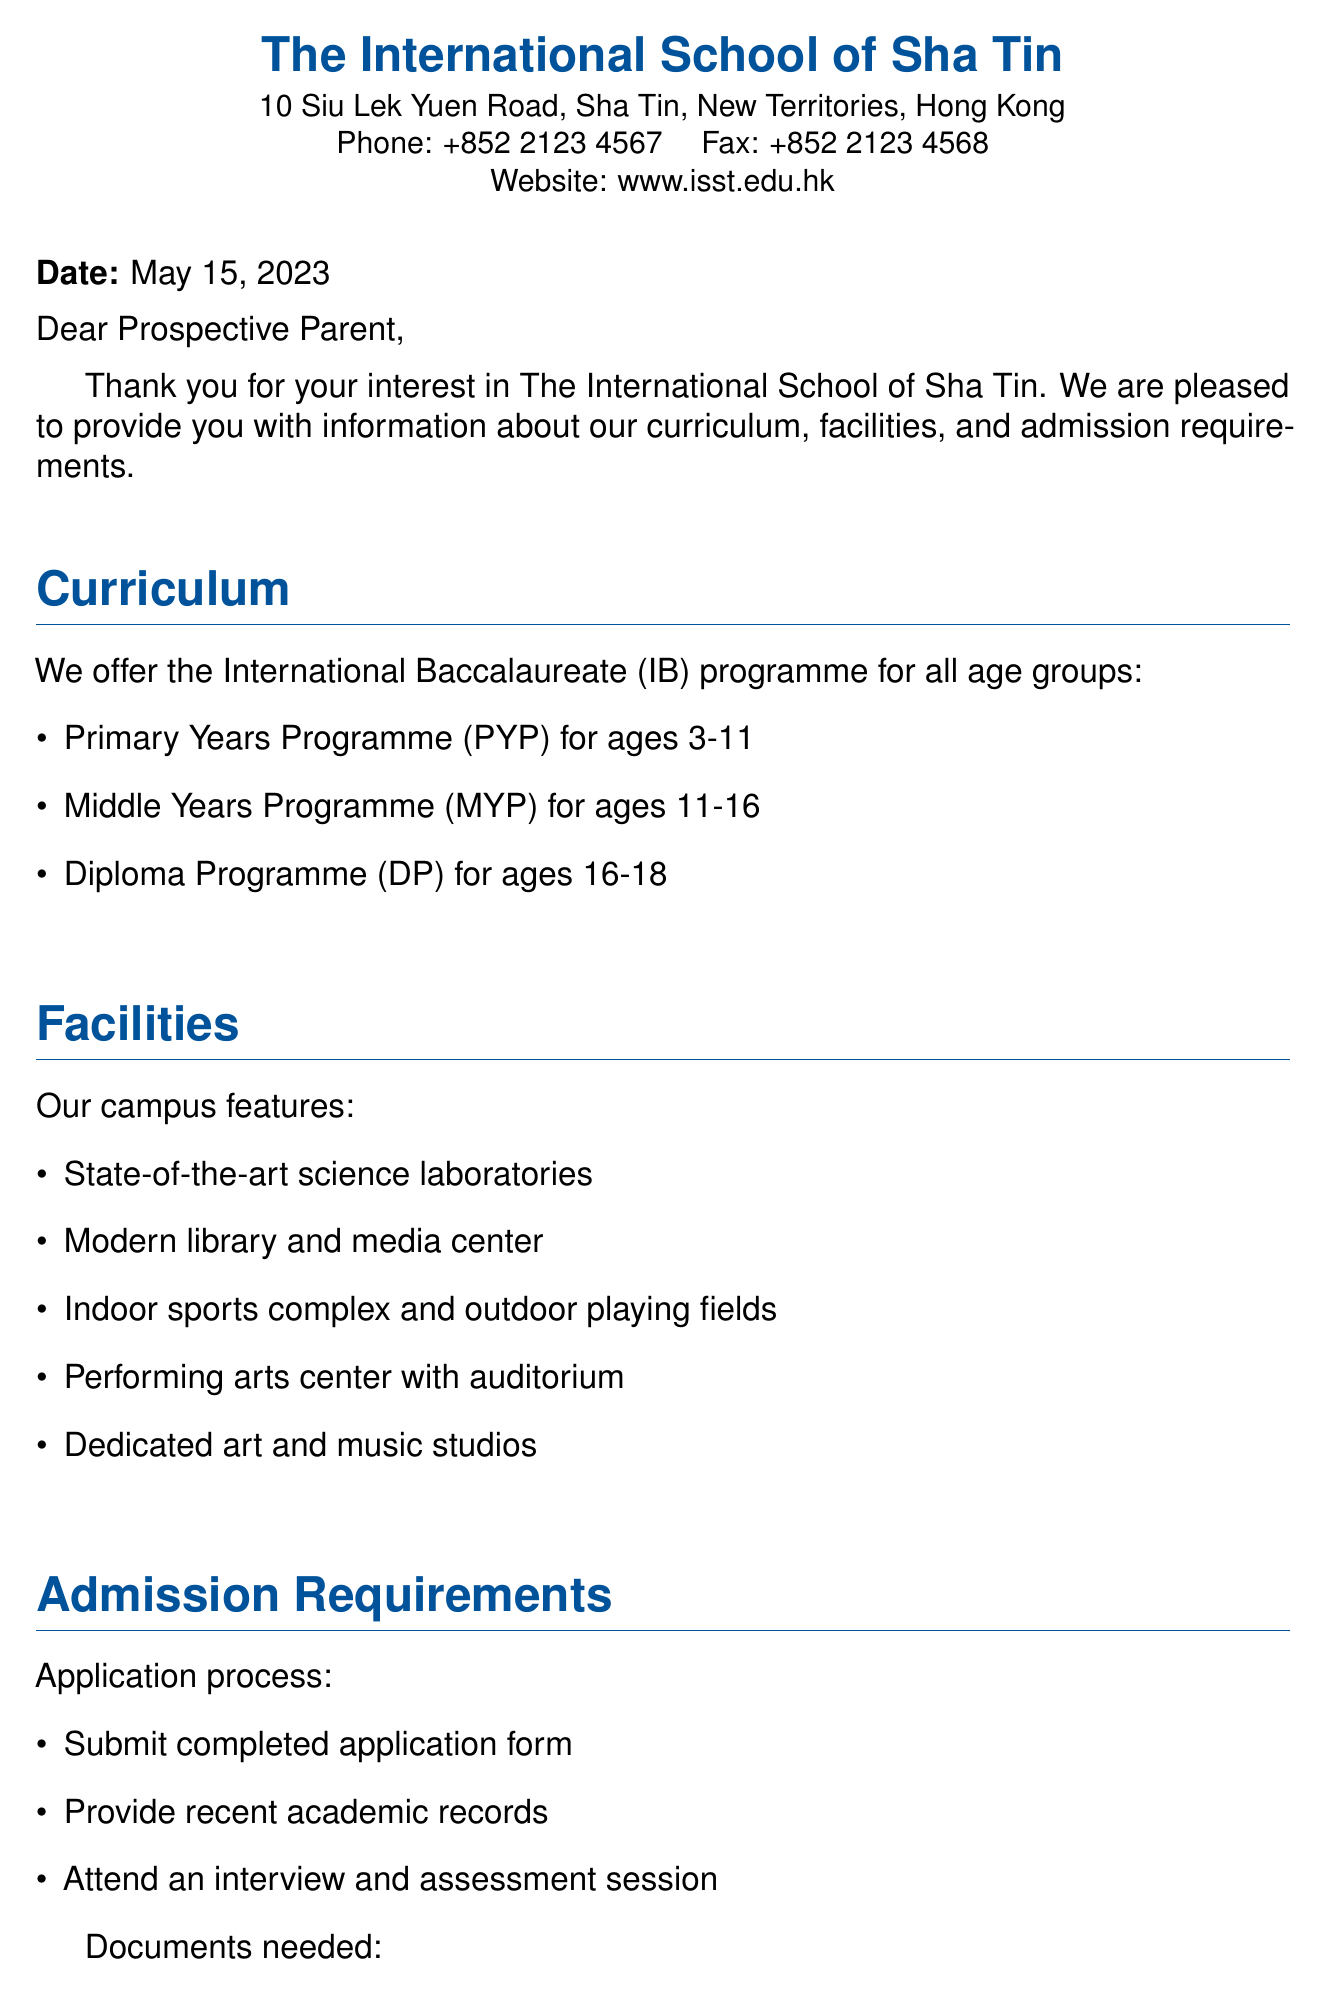What is the name of the school? The document clearly states the name of the school at the beginning, which is "The International School of Sha Tin."
Answer: The International School of Sha Tin What is the application fee? The document specifies the application fee as HKD 2,000 and states it is non-refundable.
Answer: HKD 2,000 What age group does the PYP cater to? The curriculum section indicates that the Primary Years Programme (PYP) is for ages 3-11.
Answer: Ages 3-11 Which programme is for ages 16-18? The curriculum lists the Diploma Programme (DP) as the one for ages 16-18.
Answer: Diploma Programme (DP) What facilities are mentioned in the document? The facilities section lists amenities, including science laboratories, library, sports complex, performing arts center, and art/music studios.
Answer: State-of-the-art science laboratories, modern library and media center, indoor sports complex and outdoor playing fields, performing arts center with auditorium, dedicated art and music studios What documents are required for admission? The section on admission requirements includes a list of documents needed, specifying a passport copy, photographs, and immunization records.
Answer: Passport copy, two recent passport-size photographs, immunization records Who is the Director of Admissions? The document concludes with the name of the Director of Admissions, indicated at the end of the fax.
Answer: Sarah Chen When was the fax sent? The date clearly presented in the document indicates when this information was provided to prospective parents.
Answer: May 15, 2023 